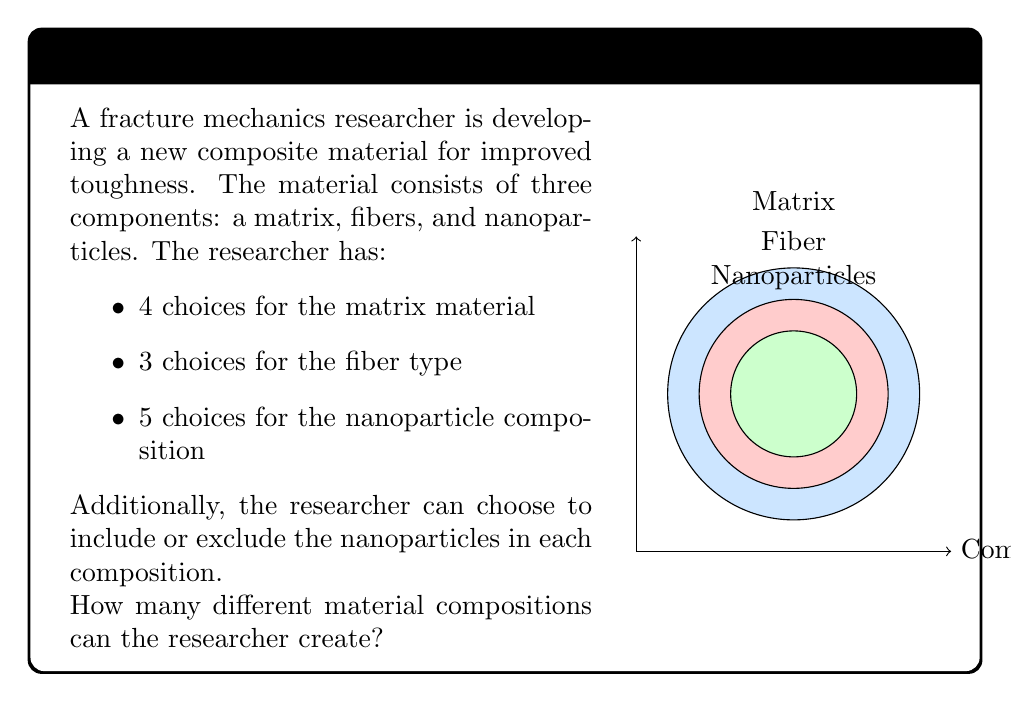Help me with this question. Let's approach this step-by-step using the multiplication principle of combinatorics:

1) First, let's consider the choices for each component:
   - Matrix: 4 choices
   - Fiber: 3 choices
   - Nanoparticles: 5 choices + 1 choice (to exclude)

2) For each composition, we must choose one matrix and one fiber type:
   $4 \times 3 = 12$ combinations

3) For the nanoparticles, we have two scenarios:
   a) Include nanoparticles: 5 choices
   b) Exclude nanoparticles: 1 choice
   Total nanoparticle options: $5 + 1 = 6$

4) Now, for each of the 12 matrix-fiber combinations, we have 6 nanoparticle options.

5) Therefore, the total number of possible compositions is:
   $$ 4 \times 3 \times 6 = 72 $$

This calculation uses the multiplication principle, where we multiply the number of choices for each independent decision to get the total number of possible outcomes.
Answer: 72 compositions 